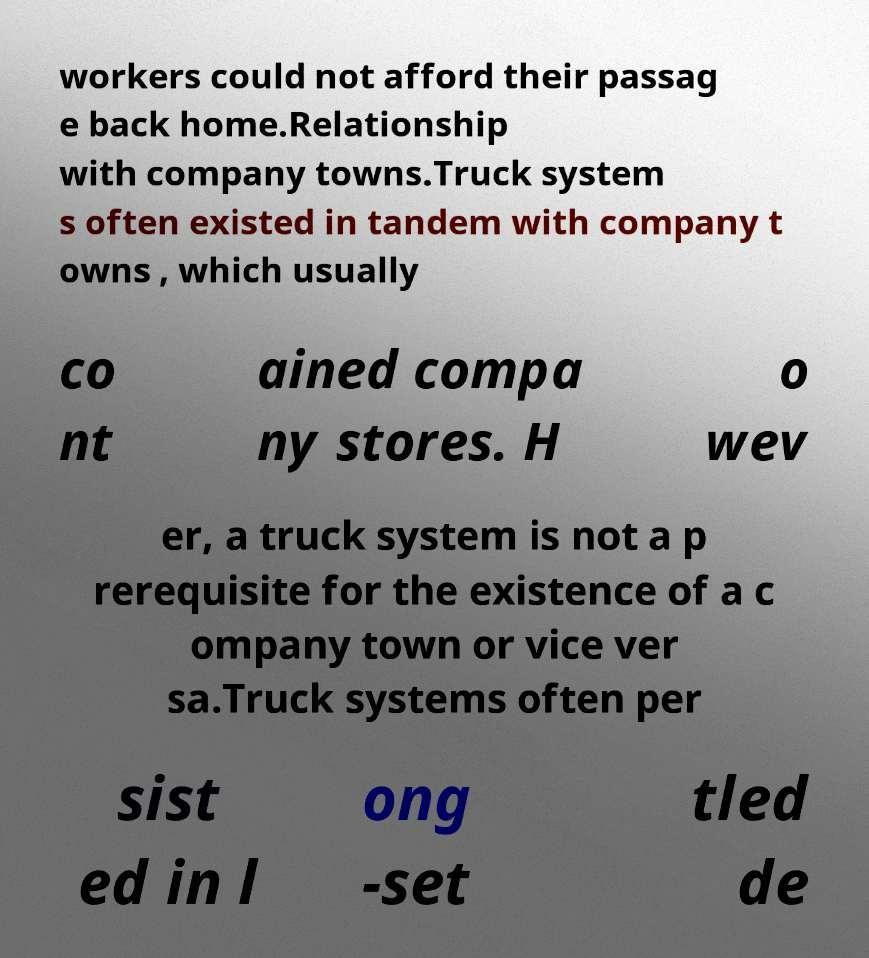For documentation purposes, I need the text within this image transcribed. Could you provide that? workers could not afford their passag e back home.Relationship with company towns.Truck system s often existed in tandem with company t owns , which usually co nt ained compa ny stores. H o wev er, a truck system is not a p rerequisite for the existence of a c ompany town or vice ver sa.Truck systems often per sist ed in l ong -set tled de 